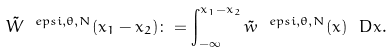Convert formula to latex. <formula><loc_0><loc_0><loc_500><loc_500>\tilde { W } ^ { \ e p s i , \theta , N } ( x _ { 1 } - x _ { 2 } ) \colon = \int _ { - \infty } ^ { x _ { 1 } - x _ { 2 } } \tilde { w } ^ { \ e p s i , \theta , N } ( x ) \ D x .</formula> 